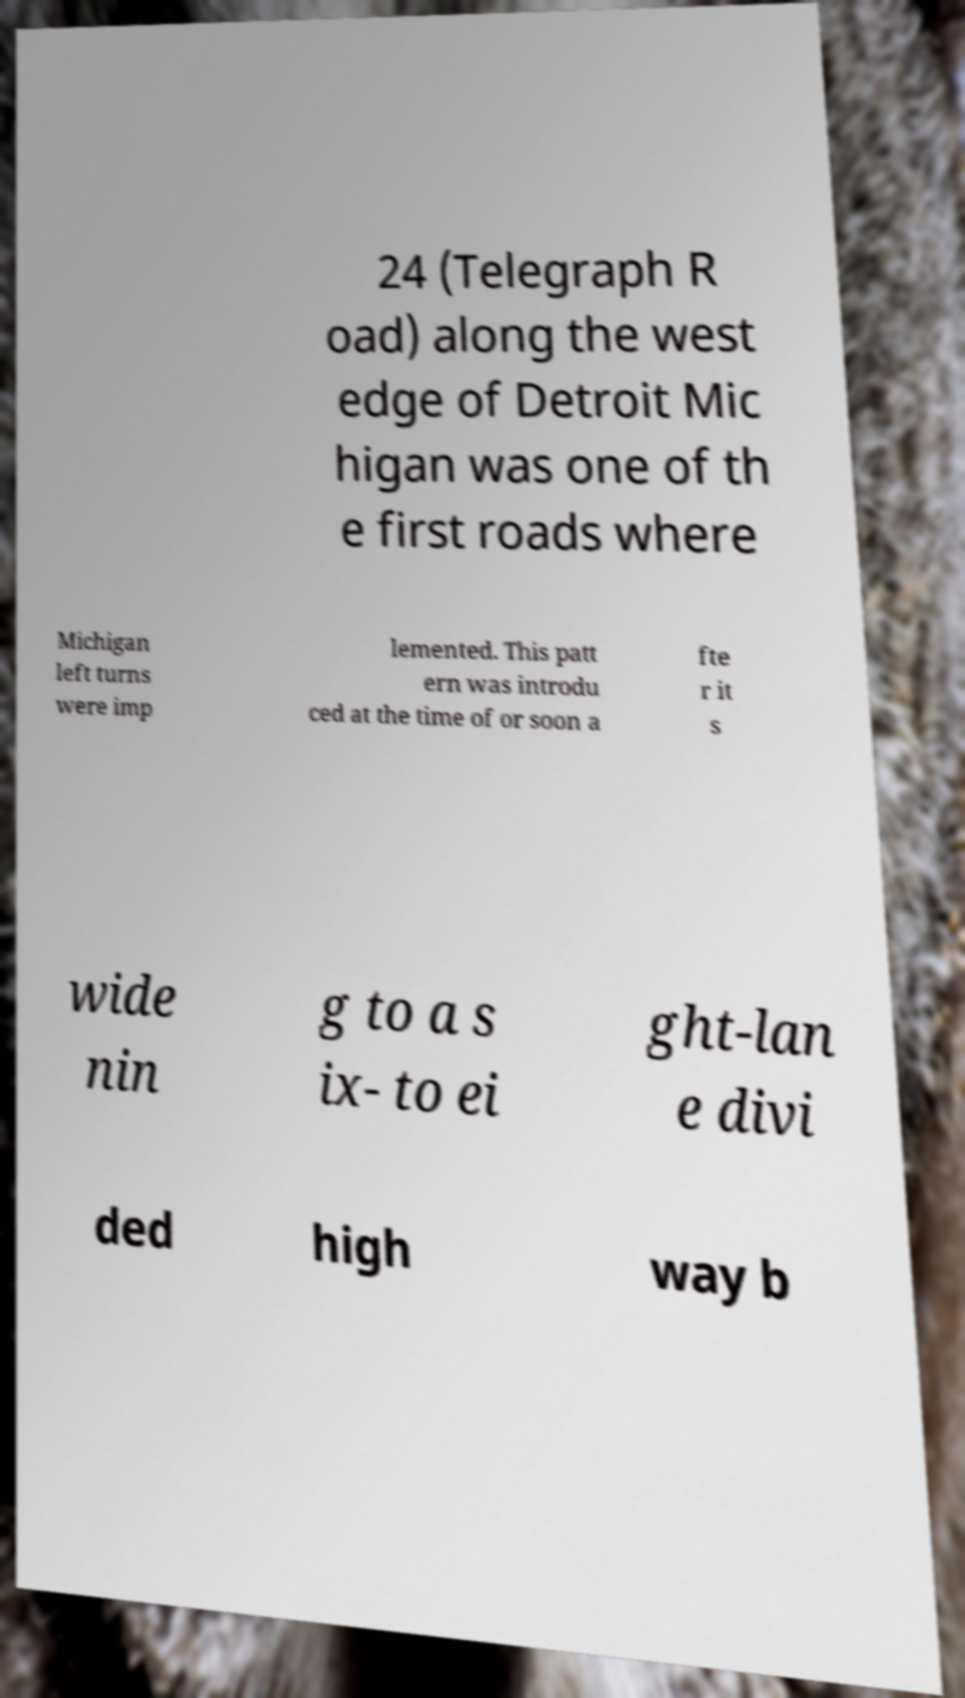Please identify and transcribe the text found in this image. 24 (Telegraph R oad) along the west edge of Detroit Mic higan was one of th e first roads where Michigan left turns were imp lemented. This patt ern was introdu ced at the time of or soon a fte r it s wide nin g to a s ix- to ei ght-lan e divi ded high way b 